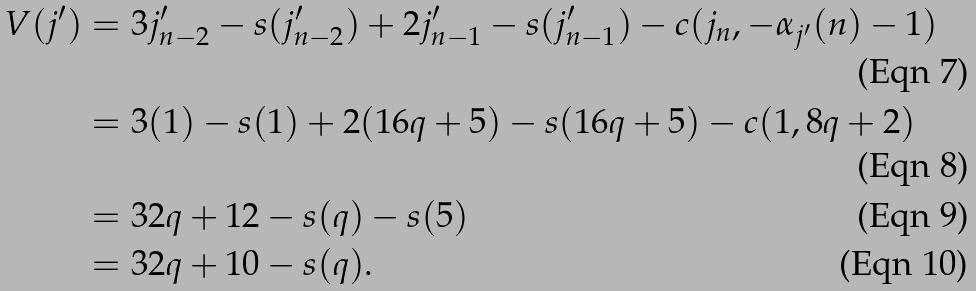<formula> <loc_0><loc_0><loc_500><loc_500>V ( j ^ { \prime } ) & = 3 j _ { n - 2 } ^ { \prime } - s ( j _ { n - 2 } ^ { \prime } ) + 2 j _ { n - 1 } ^ { \prime } - s ( j _ { n - 1 } ^ { \prime } ) - c ( j _ { n } , - \alpha _ { j ^ { \prime } } ( n ) - 1 ) \\ & = 3 ( 1 ) - s ( 1 ) + 2 ( 1 6 q + 5 ) - s ( 1 6 q + 5 ) - c ( 1 , 8 q + 2 ) \\ & = 3 2 q + 1 2 - s ( q ) - s ( 5 ) \\ & = 3 2 q + 1 0 - s ( q ) .</formula> 